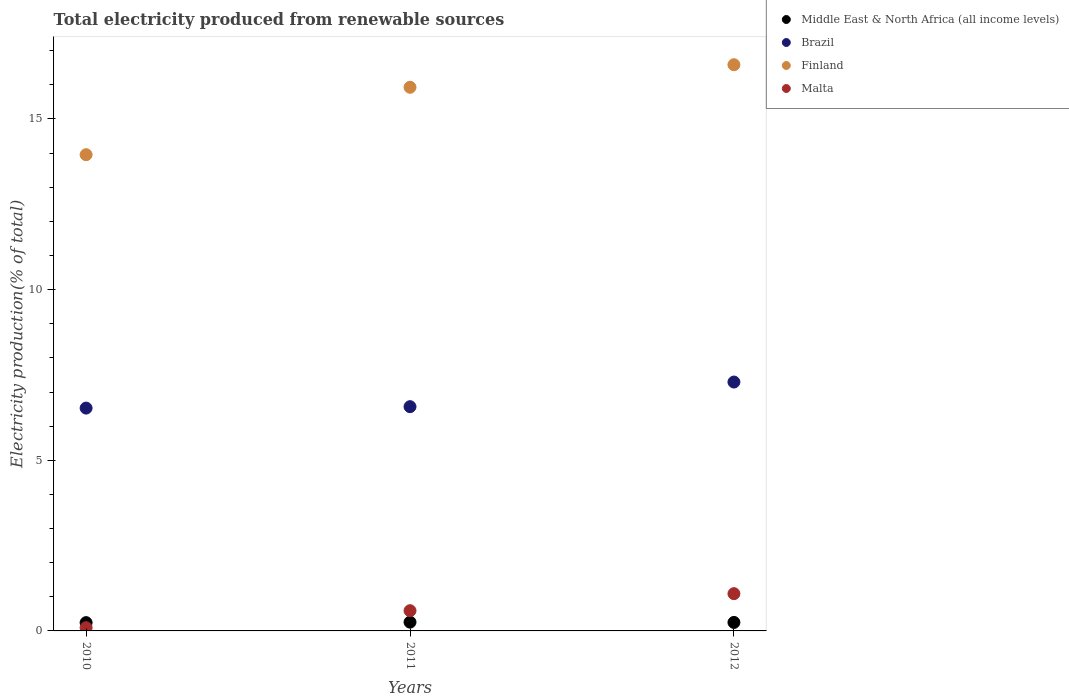How many different coloured dotlines are there?
Ensure brevity in your answer.  4. Is the number of dotlines equal to the number of legend labels?
Your answer should be compact. Yes. What is the total electricity produced in Finland in 2011?
Offer a terse response. 15.93. Across all years, what is the maximum total electricity produced in Malta?
Your answer should be compact. 1.09. Across all years, what is the minimum total electricity produced in Middle East & North Africa (all income levels)?
Offer a very short reply. 0.24. In which year was the total electricity produced in Brazil maximum?
Ensure brevity in your answer.  2012. What is the total total electricity produced in Finland in the graph?
Provide a succinct answer. 46.47. What is the difference between the total electricity produced in Middle East & North Africa (all income levels) in 2010 and that in 2011?
Your answer should be compact. -0.01. What is the difference between the total electricity produced in Middle East & North Africa (all income levels) in 2010 and the total electricity produced in Malta in 2012?
Your answer should be compact. -0.85. What is the average total electricity produced in Middle East & North Africa (all income levels) per year?
Ensure brevity in your answer.  0.25. In the year 2011, what is the difference between the total electricity produced in Finland and total electricity produced in Middle East & North Africa (all income levels)?
Make the answer very short. 15.67. What is the ratio of the total electricity produced in Finland in 2010 to that in 2011?
Provide a succinct answer. 0.88. Is the total electricity produced in Brazil in 2011 less than that in 2012?
Your answer should be very brief. Yes. What is the difference between the highest and the second highest total electricity produced in Brazil?
Offer a very short reply. 0.72. What is the difference between the highest and the lowest total electricity produced in Brazil?
Your answer should be compact. 0.76. In how many years, is the total electricity produced in Malta greater than the average total electricity produced in Malta taken over all years?
Provide a short and direct response. 1. Is the sum of the total electricity produced in Finland in 2011 and 2012 greater than the maximum total electricity produced in Brazil across all years?
Give a very brief answer. Yes. Does the total electricity produced in Brazil monotonically increase over the years?
Ensure brevity in your answer.  Yes. Is the total electricity produced in Middle East & North Africa (all income levels) strictly greater than the total electricity produced in Brazil over the years?
Provide a succinct answer. No. Is the total electricity produced in Malta strictly less than the total electricity produced in Middle East & North Africa (all income levels) over the years?
Ensure brevity in your answer.  No. Does the graph contain grids?
Your response must be concise. No. Where does the legend appear in the graph?
Offer a very short reply. Top right. How are the legend labels stacked?
Offer a very short reply. Vertical. What is the title of the graph?
Keep it short and to the point. Total electricity produced from renewable sources. Does "Micronesia" appear as one of the legend labels in the graph?
Keep it short and to the point. No. What is the label or title of the Y-axis?
Offer a very short reply. Electricity production(% of total). What is the Electricity production(% of total) in Middle East & North Africa (all income levels) in 2010?
Offer a terse response. 0.24. What is the Electricity production(% of total) in Brazil in 2010?
Provide a short and direct response. 6.53. What is the Electricity production(% of total) in Finland in 2010?
Offer a terse response. 13.95. What is the Electricity production(% of total) of Malta in 2010?
Your answer should be very brief. 0.09. What is the Electricity production(% of total) of Middle East & North Africa (all income levels) in 2011?
Ensure brevity in your answer.  0.26. What is the Electricity production(% of total) in Brazil in 2011?
Keep it short and to the point. 6.57. What is the Electricity production(% of total) of Finland in 2011?
Give a very brief answer. 15.93. What is the Electricity production(% of total) in Malta in 2011?
Keep it short and to the point. 0.59. What is the Electricity production(% of total) in Middle East & North Africa (all income levels) in 2012?
Keep it short and to the point. 0.25. What is the Electricity production(% of total) in Brazil in 2012?
Provide a succinct answer. 7.29. What is the Electricity production(% of total) in Finland in 2012?
Keep it short and to the point. 16.59. What is the Electricity production(% of total) in Malta in 2012?
Offer a very short reply. 1.09. Across all years, what is the maximum Electricity production(% of total) of Middle East & North Africa (all income levels)?
Offer a terse response. 0.26. Across all years, what is the maximum Electricity production(% of total) in Brazil?
Give a very brief answer. 7.29. Across all years, what is the maximum Electricity production(% of total) of Finland?
Ensure brevity in your answer.  16.59. Across all years, what is the maximum Electricity production(% of total) of Malta?
Your response must be concise. 1.09. Across all years, what is the minimum Electricity production(% of total) in Middle East & North Africa (all income levels)?
Your answer should be compact. 0.24. Across all years, what is the minimum Electricity production(% of total) in Brazil?
Provide a succinct answer. 6.53. Across all years, what is the minimum Electricity production(% of total) in Finland?
Ensure brevity in your answer.  13.95. Across all years, what is the minimum Electricity production(% of total) in Malta?
Your response must be concise. 0.09. What is the total Electricity production(% of total) of Middle East & North Africa (all income levels) in the graph?
Your response must be concise. 0.75. What is the total Electricity production(% of total) of Brazil in the graph?
Provide a succinct answer. 20.39. What is the total Electricity production(% of total) in Finland in the graph?
Keep it short and to the point. 46.47. What is the total Electricity production(% of total) in Malta in the graph?
Ensure brevity in your answer.  1.78. What is the difference between the Electricity production(% of total) of Middle East & North Africa (all income levels) in 2010 and that in 2011?
Ensure brevity in your answer.  -0.01. What is the difference between the Electricity production(% of total) of Brazil in 2010 and that in 2011?
Keep it short and to the point. -0.04. What is the difference between the Electricity production(% of total) of Finland in 2010 and that in 2011?
Your answer should be compact. -1.98. What is the difference between the Electricity production(% of total) of Malta in 2010 and that in 2011?
Ensure brevity in your answer.  -0.5. What is the difference between the Electricity production(% of total) of Middle East & North Africa (all income levels) in 2010 and that in 2012?
Offer a very short reply. -0.01. What is the difference between the Electricity production(% of total) of Brazil in 2010 and that in 2012?
Give a very brief answer. -0.76. What is the difference between the Electricity production(% of total) of Finland in 2010 and that in 2012?
Your response must be concise. -2.64. What is the difference between the Electricity production(% of total) of Malta in 2010 and that in 2012?
Offer a very short reply. -1. What is the difference between the Electricity production(% of total) of Middle East & North Africa (all income levels) in 2011 and that in 2012?
Give a very brief answer. 0.01. What is the difference between the Electricity production(% of total) of Brazil in 2011 and that in 2012?
Provide a short and direct response. -0.72. What is the difference between the Electricity production(% of total) of Finland in 2011 and that in 2012?
Your response must be concise. -0.66. What is the difference between the Electricity production(% of total) in Malta in 2011 and that in 2012?
Provide a succinct answer. -0.5. What is the difference between the Electricity production(% of total) in Middle East & North Africa (all income levels) in 2010 and the Electricity production(% of total) in Brazil in 2011?
Your response must be concise. -6.33. What is the difference between the Electricity production(% of total) in Middle East & North Africa (all income levels) in 2010 and the Electricity production(% of total) in Finland in 2011?
Keep it short and to the point. -15.69. What is the difference between the Electricity production(% of total) in Middle East & North Africa (all income levels) in 2010 and the Electricity production(% of total) in Malta in 2011?
Provide a short and direct response. -0.35. What is the difference between the Electricity production(% of total) of Brazil in 2010 and the Electricity production(% of total) of Finland in 2011?
Offer a very short reply. -9.4. What is the difference between the Electricity production(% of total) of Brazil in 2010 and the Electricity production(% of total) of Malta in 2011?
Ensure brevity in your answer.  5.94. What is the difference between the Electricity production(% of total) in Finland in 2010 and the Electricity production(% of total) in Malta in 2011?
Your answer should be compact. 13.36. What is the difference between the Electricity production(% of total) of Middle East & North Africa (all income levels) in 2010 and the Electricity production(% of total) of Brazil in 2012?
Offer a terse response. -7.05. What is the difference between the Electricity production(% of total) of Middle East & North Africa (all income levels) in 2010 and the Electricity production(% of total) of Finland in 2012?
Your answer should be very brief. -16.35. What is the difference between the Electricity production(% of total) in Middle East & North Africa (all income levels) in 2010 and the Electricity production(% of total) in Malta in 2012?
Make the answer very short. -0.85. What is the difference between the Electricity production(% of total) in Brazil in 2010 and the Electricity production(% of total) in Finland in 2012?
Keep it short and to the point. -10.06. What is the difference between the Electricity production(% of total) of Brazil in 2010 and the Electricity production(% of total) of Malta in 2012?
Give a very brief answer. 5.44. What is the difference between the Electricity production(% of total) of Finland in 2010 and the Electricity production(% of total) of Malta in 2012?
Ensure brevity in your answer.  12.86. What is the difference between the Electricity production(% of total) in Middle East & North Africa (all income levels) in 2011 and the Electricity production(% of total) in Brazil in 2012?
Offer a very short reply. -7.04. What is the difference between the Electricity production(% of total) in Middle East & North Africa (all income levels) in 2011 and the Electricity production(% of total) in Finland in 2012?
Your answer should be very brief. -16.33. What is the difference between the Electricity production(% of total) of Middle East & North Africa (all income levels) in 2011 and the Electricity production(% of total) of Malta in 2012?
Make the answer very short. -0.83. What is the difference between the Electricity production(% of total) of Brazil in 2011 and the Electricity production(% of total) of Finland in 2012?
Offer a very short reply. -10.02. What is the difference between the Electricity production(% of total) in Brazil in 2011 and the Electricity production(% of total) in Malta in 2012?
Give a very brief answer. 5.48. What is the difference between the Electricity production(% of total) of Finland in 2011 and the Electricity production(% of total) of Malta in 2012?
Ensure brevity in your answer.  14.84. What is the average Electricity production(% of total) in Middle East & North Africa (all income levels) per year?
Make the answer very short. 0.25. What is the average Electricity production(% of total) in Brazil per year?
Keep it short and to the point. 6.8. What is the average Electricity production(% of total) in Finland per year?
Offer a terse response. 15.49. What is the average Electricity production(% of total) in Malta per year?
Your answer should be compact. 0.59. In the year 2010, what is the difference between the Electricity production(% of total) in Middle East & North Africa (all income levels) and Electricity production(% of total) in Brazil?
Your answer should be very brief. -6.29. In the year 2010, what is the difference between the Electricity production(% of total) of Middle East & North Africa (all income levels) and Electricity production(% of total) of Finland?
Offer a very short reply. -13.71. In the year 2010, what is the difference between the Electricity production(% of total) in Middle East & North Africa (all income levels) and Electricity production(% of total) in Malta?
Offer a very short reply. 0.15. In the year 2010, what is the difference between the Electricity production(% of total) of Brazil and Electricity production(% of total) of Finland?
Your answer should be compact. -7.42. In the year 2010, what is the difference between the Electricity production(% of total) of Brazil and Electricity production(% of total) of Malta?
Give a very brief answer. 6.43. In the year 2010, what is the difference between the Electricity production(% of total) of Finland and Electricity production(% of total) of Malta?
Keep it short and to the point. 13.86. In the year 2011, what is the difference between the Electricity production(% of total) in Middle East & North Africa (all income levels) and Electricity production(% of total) in Brazil?
Your answer should be compact. -6.31. In the year 2011, what is the difference between the Electricity production(% of total) in Middle East & North Africa (all income levels) and Electricity production(% of total) in Finland?
Your response must be concise. -15.67. In the year 2011, what is the difference between the Electricity production(% of total) in Middle East & North Africa (all income levels) and Electricity production(% of total) in Malta?
Give a very brief answer. -0.34. In the year 2011, what is the difference between the Electricity production(% of total) in Brazil and Electricity production(% of total) in Finland?
Your answer should be very brief. -9.36. In the year 2011, what is the difference between the Electricity production(% of total) of Brazil and Electricity production(% of total) of Malta?
Give a very brief answer. 5.98. In the year 2011, what is the difference between the Electricity production(% of total) of Finland and Electricity production(% of total) of Malta?
Offer a very short reply. 15.34. In the year 2012, what is the difference between the Electricity production(% of total) in Middle East & North Africa (all income levels) and Electricity production(% of total) in Brazil?
Ensure brevity in your answer.  -7.04. In the year 2012, what is the difference between the Electricity production(% of total) in Middle East & North Africa (all income levels) and Electricity production(% of total) in Finland?
Your answer should be very brief. -16.34. In the year 2012, what is the difference between the Electricity production(% of total) of Middle East & North Africa (all income levels) and Electricity production(% of total) of Malta?
Provide a succinct answer. -0.84. In the year 2012, what is the difference between the Electricity production(% of total) of Brazil and Electricity production(% of total) of Finland?
Ensure brevity in your answer.  -9.3. In the year 2012, what is the difference between the Electricity production(% of total) of Brazil and Electricity production(% of total) of Malta?
Provide a short and direct response. 6.2. In the year 2012, what is the difference between the Electricity production(% of total) of Finland and Electricity production(% of total) of Malta?
Your response must be concise. 15.5. What is the ratio of the Electricity production(% of total) of Middle East & North Africa (all income levels) in 2010 to that in 2011?
Provide a succinct answer. 0.94. What is the ratio of the Electricity production(% of total) in Brazil in 2010 to that in 2011?
Provide a short and direct response. 0.99. What is the ratio of the Electricity production(% of total) in Finland in 2010 to that in 2011?
Offer a very short reply. 0.88. What is the ratio of the Electricity production(% of total) in Malta in 2010 to that in 2011?
Your answer should be compact. 0.16. What is the ratio of the Electricity production(% of total) of Middle East & North Africa (all income levels) in 2010 to that in 2012?
Your answer should be compact. 0.98. What is the ratio of the Electricity production(% of total) in Brazil in 2010 to that in 2012?
Ensure brevity in your answer.  0.9. What is the ratio of the Electricity production(% of total) in Finland in 2010 to that in 2012?
Keep it short and to the point. 0.84. What is the ratio of the Electricity production(% of total) in Malta in 2010 to that in 2012?
Offer a terse response. 0.09. What is the ratio of the Electricity production(% of total) in Middle East & North Africa (all income levels) in 2011 to that in 2012?
Your response must be concise. 1.03. What is the ratio of the Electricity production(% of total) in Brazil in 2011 to that in 2012?
Offer a very short reply. 0.9. What is the ratio of the Electricity production(% of total) in Finland in 2011 to that in 2012?
Your response must be concise. 0.96. What is the ratio of the Electricity production(% of total) of Malta in 2011 to that in 2012?
Keep it short and to the point. 0.54. What is the difference between the highest and the second highest Electricity production(% of total) of Middle East & North Africa (all income levels)?
Your answer should be very brief. 0.01. What is the difference between the highest and the second highest Electricity production(% of total) in Brazil?
Your answer should be compact. 0.72. What is the difference between the highest and the second highest Electricity production(% of total) in Finland?
Provide a short and direct response. 0.66. What is the difference between the highest and the second highest Electricity production(% of total) of Malta?
Your answer should be compact. 0.5. What is the difference between the highest and the lowest Electricity production(% of total) in Middle East & North Africa (all income levels)?
Your response must be concise. 0.01. What is the difference between the highest and the lowest Electricity production(% of total) of Brazil?
Your answer should be compact. 0.76. What is the difference between the highest and the lowest Electricity production(% of total) of Finland?
Your response must be concise. 2.64. What is the difference between the highest and the lowest Electricity production(% of total) in Malta?
Offer a terse response. 1. 